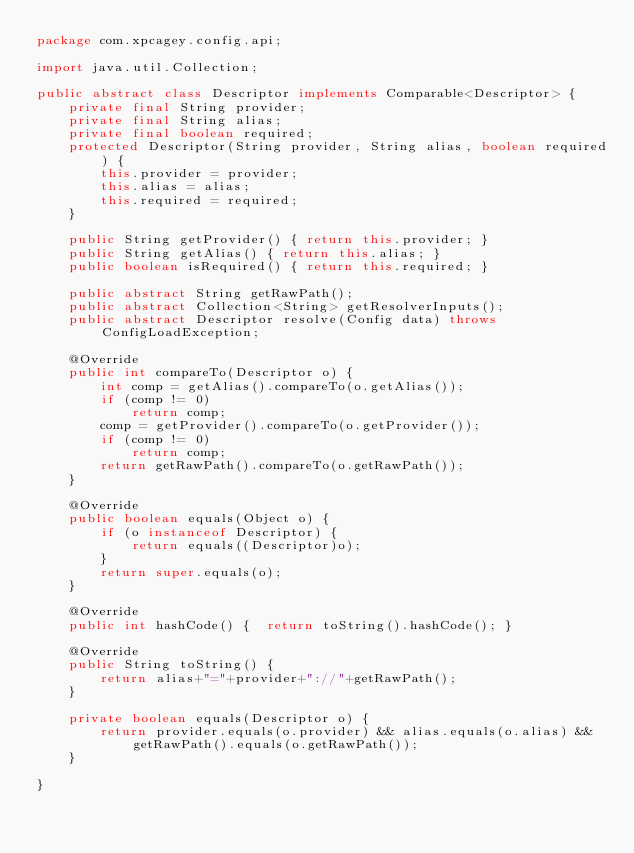Convert code to text. <code><loc_0><loc_0><loc_500><loc_500><_Java_>package com.xpcagey.config.api;

import java.util.Collection;

public abstract class Descriptor implements Comparable<Descriptor> {
    private final String provider;
    private final String alias;
    private final boolean required;
    protected Descriptor(String provider, String alias, boolean required) {
        this.provider = provider;
        this.alias = alias;
        this.required = required;
    }

    public String getProvider() { return this.provider; }
    public String getAlias() { return this.alias; }
    public boolean isRequired() { return this.required; }

    public abstract String getRawPath();
    public abstract Collection<String> getResolverInputs();
    public abstract Descriptor resolve(Config data) throws ConfigLoadException;

    @Override
    public int compareTo(Descriptor o) {
        int comp = getAlias().compareTo(o.getAlias());
        if (comp != 0)
            return comp;
        comp = getProvider().compareTo(o.getProvider());
        if (comp != 0)
            return comp;
        return getRawPath().compareTo(o.getRawPath());
    }

    @Override
    public boolean equals(Object o) {
        if (o instanceof Descriptor) {
            return equals((Descriptor)o);
        }
        return super.equals(o);
    }

    @Override
    public int hashCode() {  return toString().hashCode(); }

    @Override
    public String toString() {
        return alias+"="+provider+"://"+getRawPath();
    }

    private boolean equals(Descriptor o) {
        return provider.equals(o.provider) && alias.equals(o.alias) && getRawPath().equals(o.getRawPath());
    }

}
</code> 